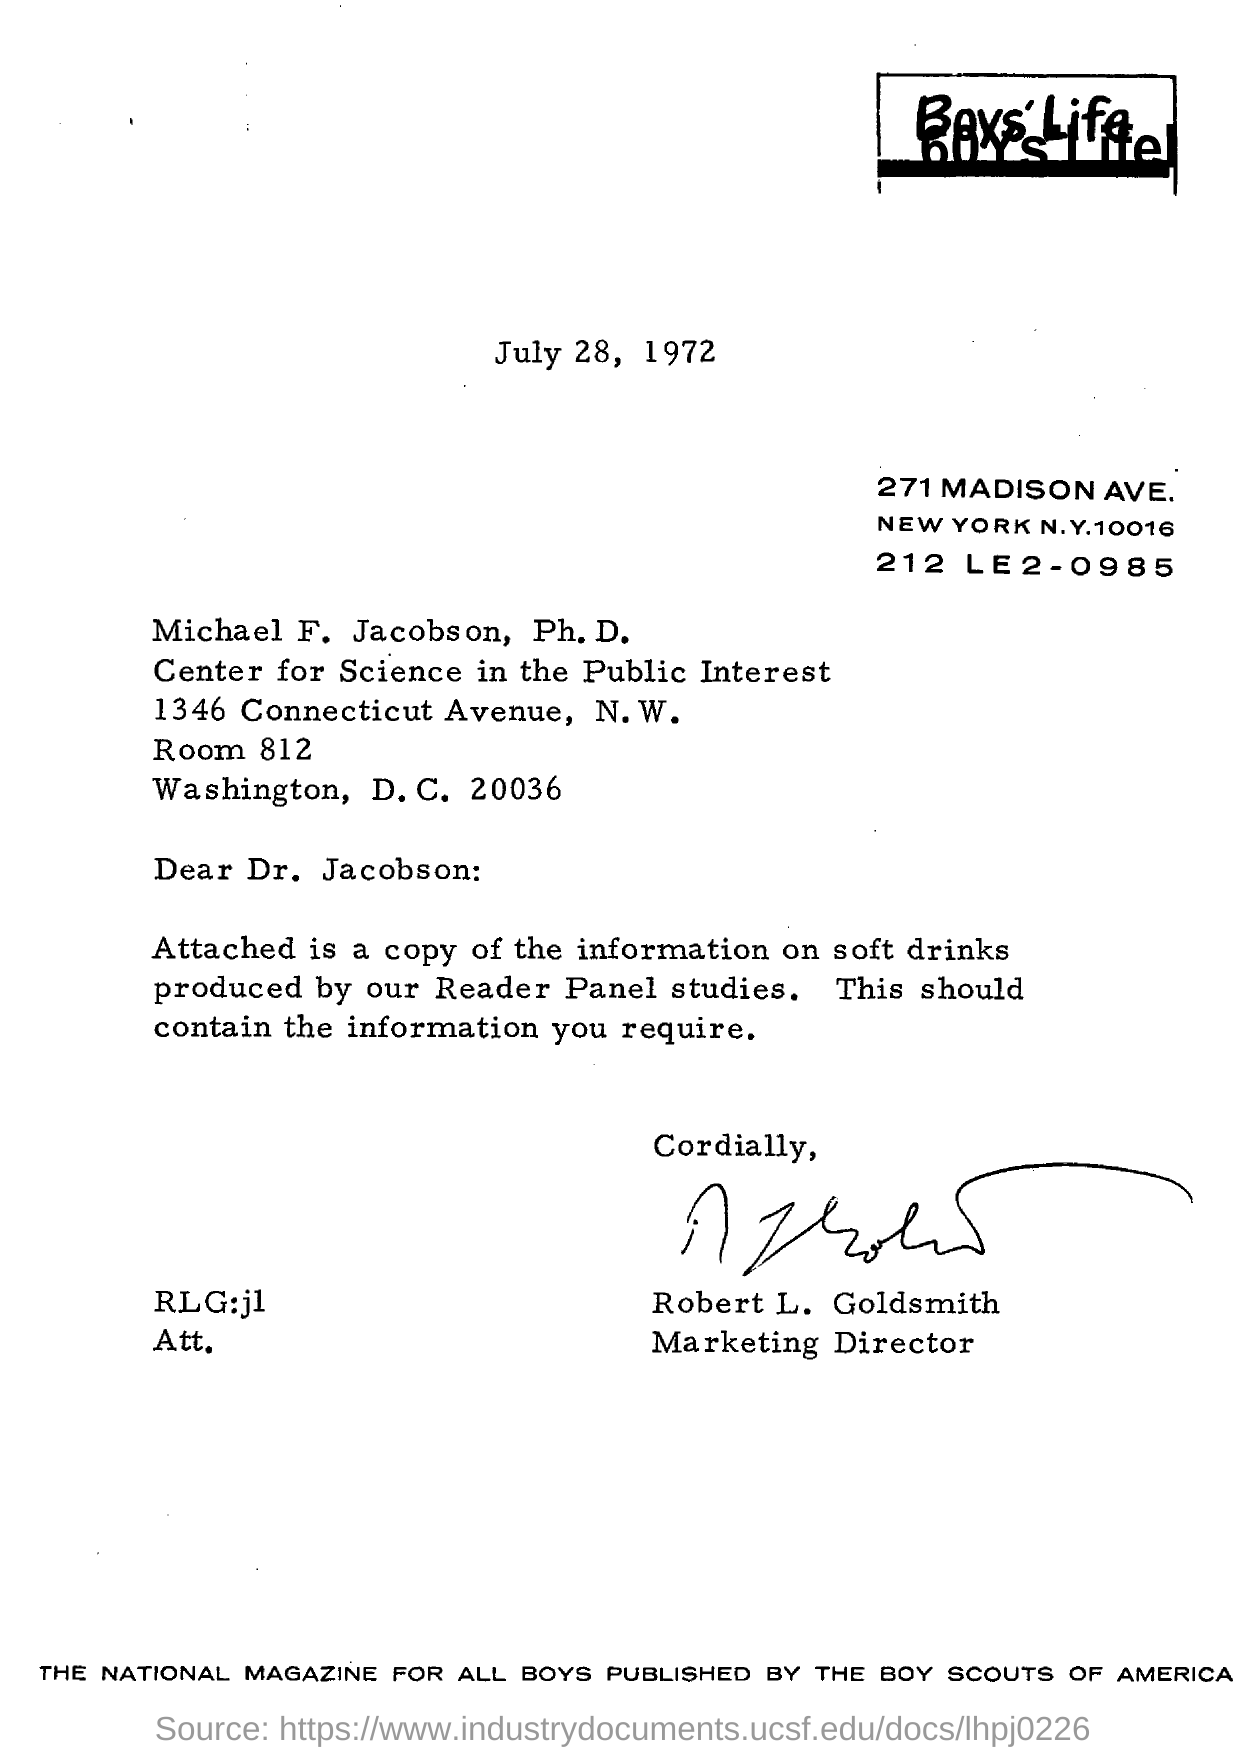What is the date mentioned in the letter?
Give a very brief answer. July 28, 1972. Who is marketing director?
Your response must be concise. Robert L. Goldsmith. Who published the national magazine for all boys ?
Your answer should be very brief. The boy scouts of america. 